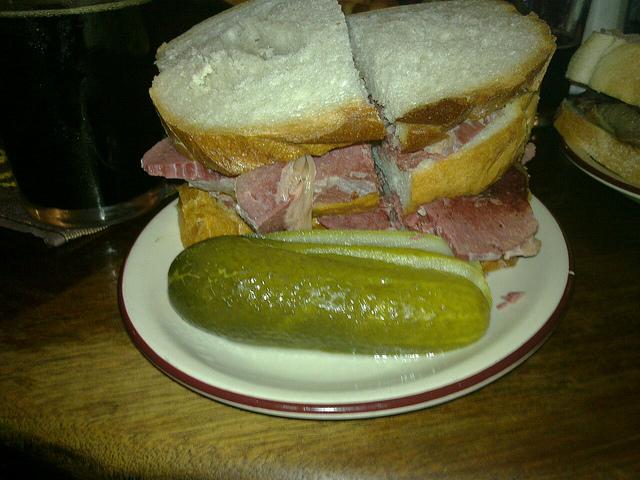What is that?
Write a very short answer. Sandwich and pickle. What is white on the plate?
Answer briefly. Bread. What is green on the plate?
Keep it brief. Pickle. Is this soup?
Write a very short answer. No. Is this food sweet?
Concise answer only. No. The designs on the plates are?
Quick response, please. Solid. What meat is on this sandwich?
Answer briefly. Ham. Where is the pickle?
Write a very short answer. On plate. Why is the sandwich, with a pickle, on the table?
Keep it brief. To be eaten. Is that a lime?
Answer briefly. No. Is this at a restaurant?
Concise answer only. Yes. What is the long fruit?
Concise answer only. Pickle. What color is the trim on the plate?
Write a very short answer. Red. What fruit is this?
Keep it brief. Pickle. Is there a sandwich on the plate?
Answer briefly. Yes. What is the table top made of?
Concise answer only. Wood. 